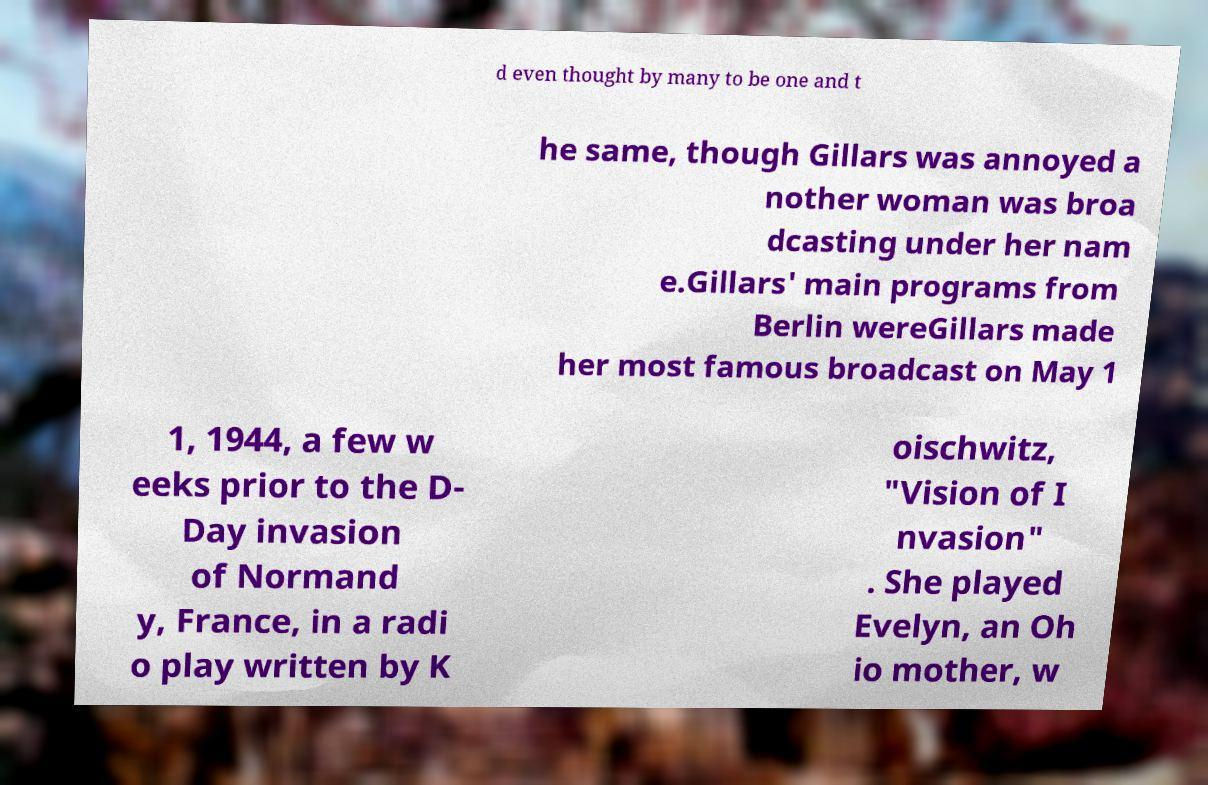For documentation purposes, I need the text within this image transcribed. Could you provide that? d even thought by many to be one and t he same, though Gillars was annoyed a nother woman was broa dcasting under her nam e.Gillars' main programs from Berlin wereGillars made her most famous broadcast on May 1 1, 1944, a few w eeks prior to the D- Day invasion of Normand y, France, in a radi o play written by K oischwitz, "Vision of I nvasion" . She played Evelyn, an Oh io mother, w 